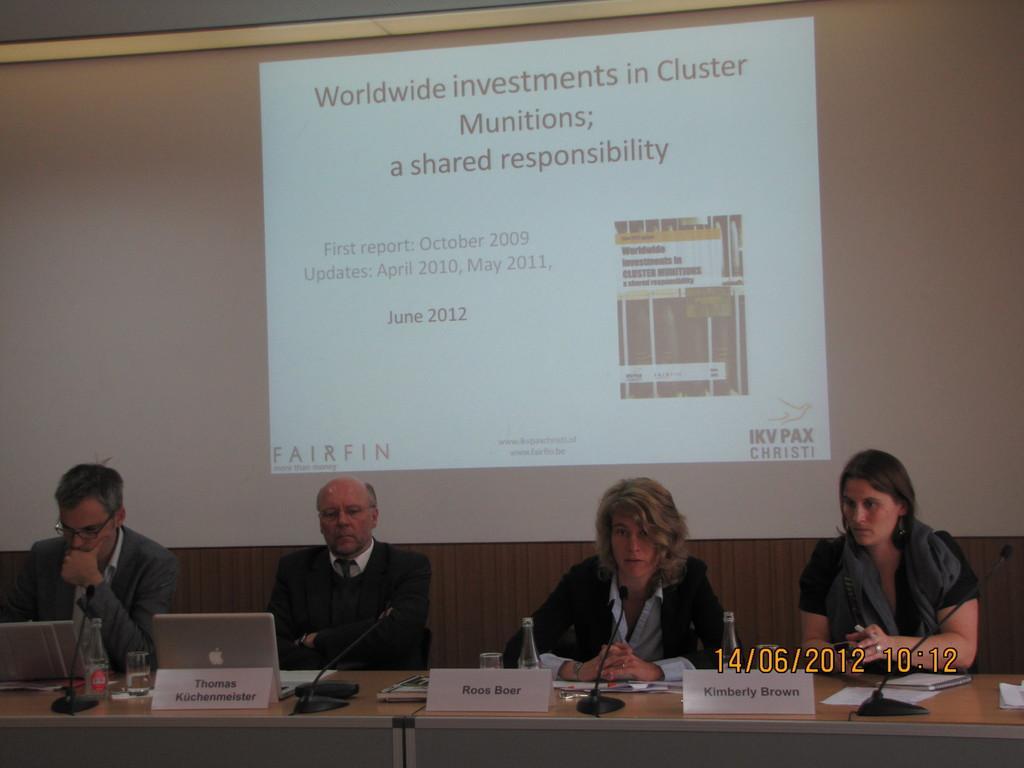Please provide a concise description of this image. In this picture I can see four persons sitting, there are papers, mike's, glasses, nameplates, bottles and laptops on the table, and in the background there is a screen and there is a watermark on the image. 